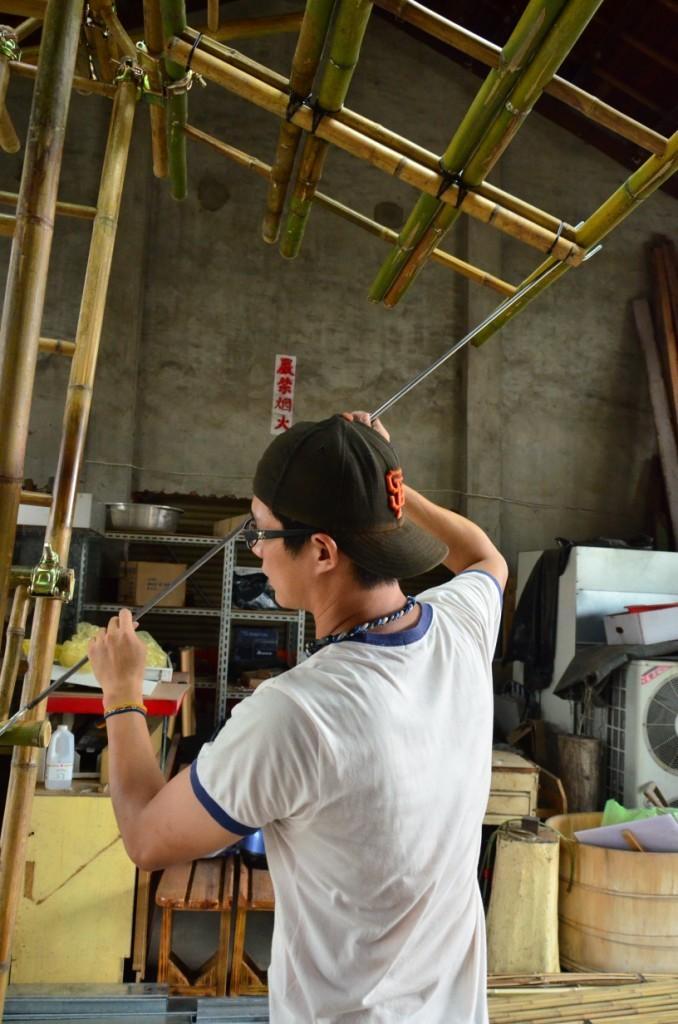Can you describe this image briefly? In this image I can see a man is standing in the front, I can see he is wearing a black color cap, specs and white color t shirt. I can also see he is holding a black color thing. In the background I can see number of stuffs, a bottle, few boxes and a white color board on the wall. I can also see number of wooden poles on the left and on the top side of this image. 